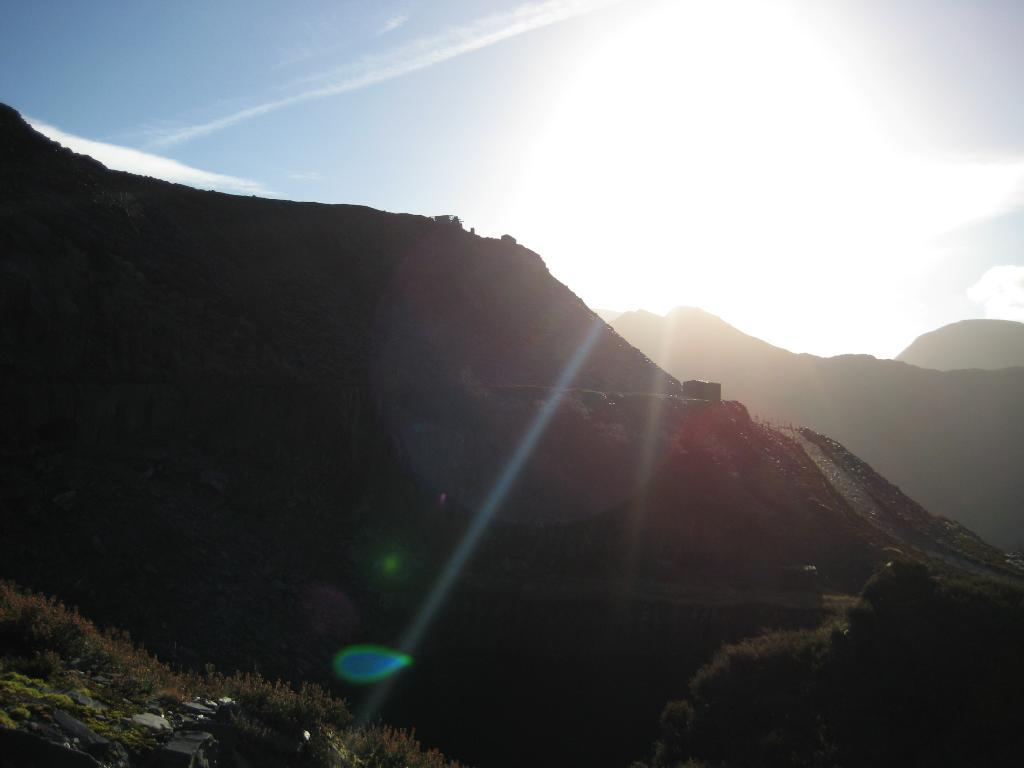What type of natural formation can be seen in the image? There are mountains in the image. What else is present on the mountains? There are trees on the mountains. What can be seen in the background of the image? The sky is visible in the background of the image. What celestial body is observable in the sky? The sun is observable in the sky. Can you see any fairies flying around the trees on the mountains in the image? There are no fairies present in the image; it features mountains with trees and a sky with the sun. Is there a maid visible in the image, preparing a meal on the mountains? There is no maid present in the image; it features mountains with trees and a sky with the sun. 